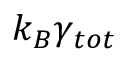<formula> <loc_0><loc_0><loc_500><loc_500>k _ { B } \gamma _ { t o t }</formula> 